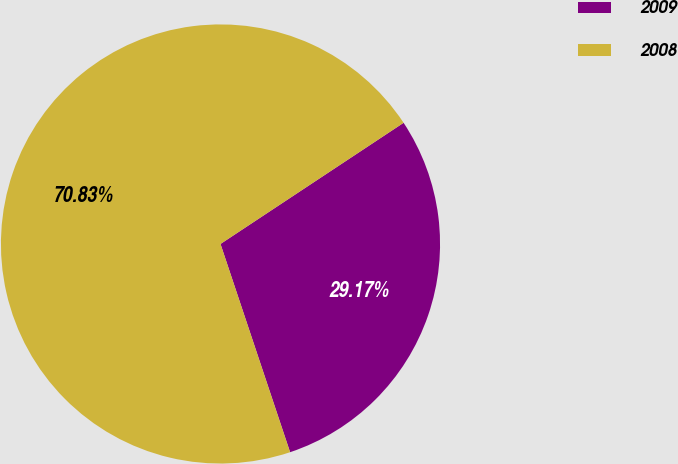<chart> <loc_0><loc_0><loc_500><loc_500><pie_chart><fcel>2009<fcel>2008<nl><fcel>29.17%<fcel>70.83%<nl></chart> 